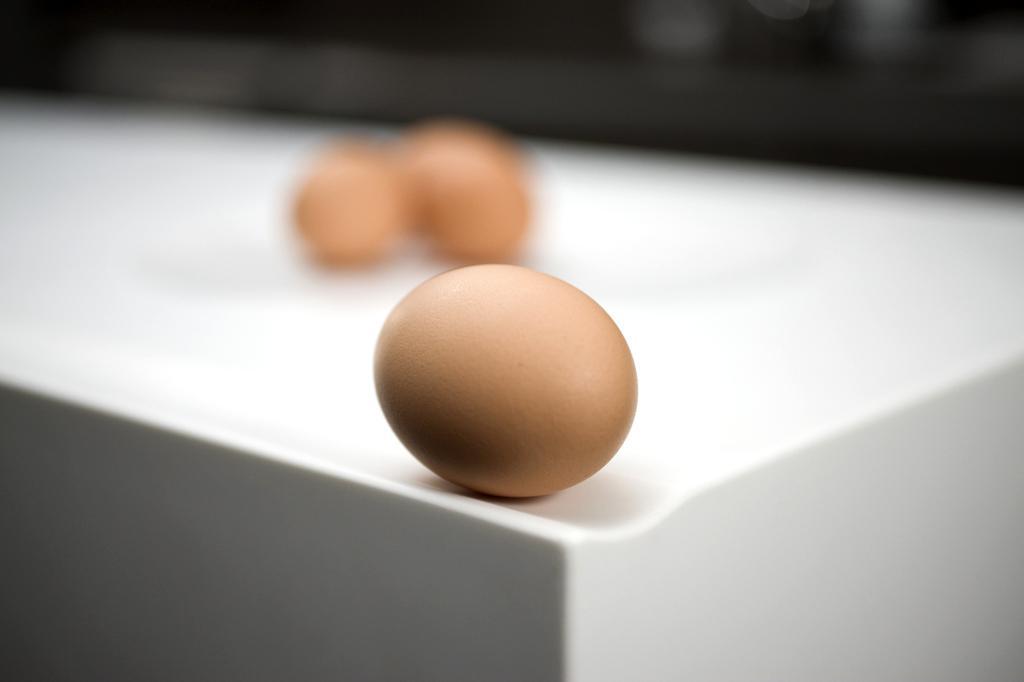Describe this image in one or two sentences. In the middle of the image we can see a table, on the table we can see some eggs. Background of the image is blur. 